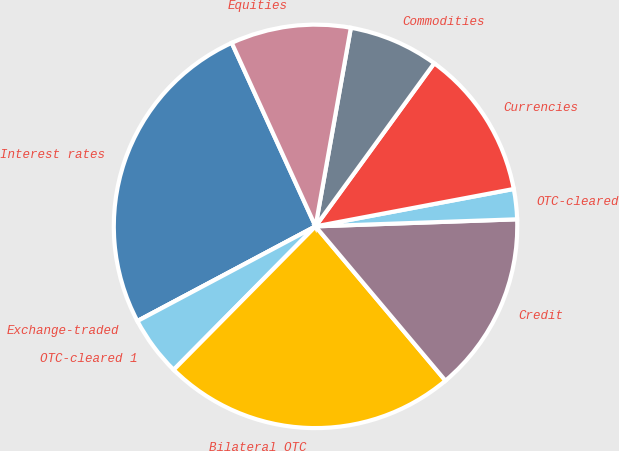Convert chart to OTSL. <chart><loc_0><loc_0><loc_500><loc_500><pie_chart><fcel>Interest rates<fcel>Exchange-traded<fcel>OTC-cleared 1<fcel>Bilateral OTC<fcel>Credit<fcel>OTC-cleared<fcel>Currencies<fcel>Commodities<fcel>Equities<nl><fcel>25.96%<fcel>0.0%<fcel>4.81%<fcel>23.55%<fcel>14.42%<fcel>2.41%<fcel>12.02%<fcel>7.21%<fcel>9.62%<nl></chart> 